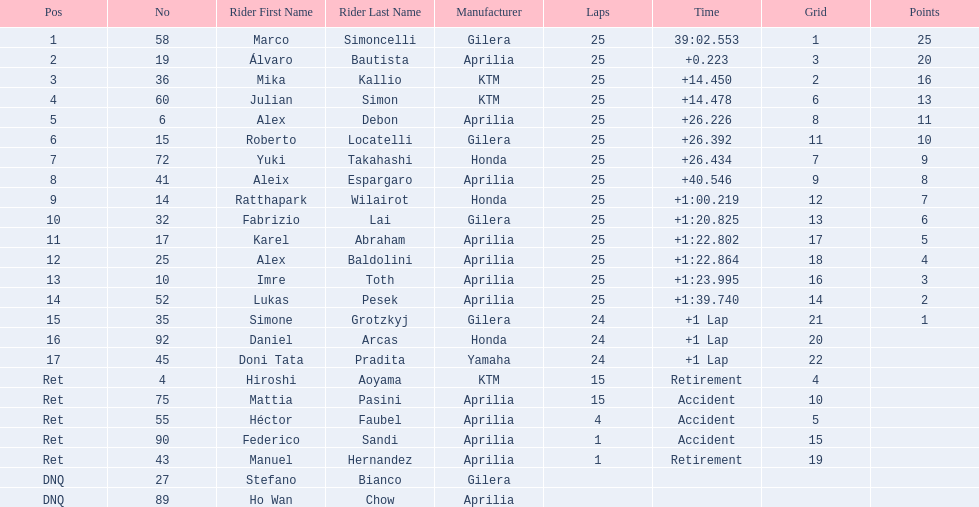Who were all of the riders? Marco Simoncelli, Álvaro Bautista, Mika Kallio, Julian Simon, Alex Debon, Roberto Locatelli, Yuki Takahashi, Aleix Espargaro, Ratthapark Wilairot, Fabrizio Lai, Karel Abraham, Alex Baldolini, Imre Toth, Lukas Pesek, Simone Grotzkyj, Daniel Arcas, Doni Tata Pradita, Hiroshi Aoyama, Mattia Pasini, Héctor Faubel, Federico Sandi, Manuel Hernandez, Stefano Bianco, Ho Wan Chow. How many laps did they complete? 25, 25, 25, 25, 25, 25, 25, 25, 25, 25, 25, 25, 25, 25, 24, 24, 24, 15, 15, 4, 1, 1, , . Between marco simoncelli and hiroshi aoyama, who had more laps? Marco Simoncelli. 